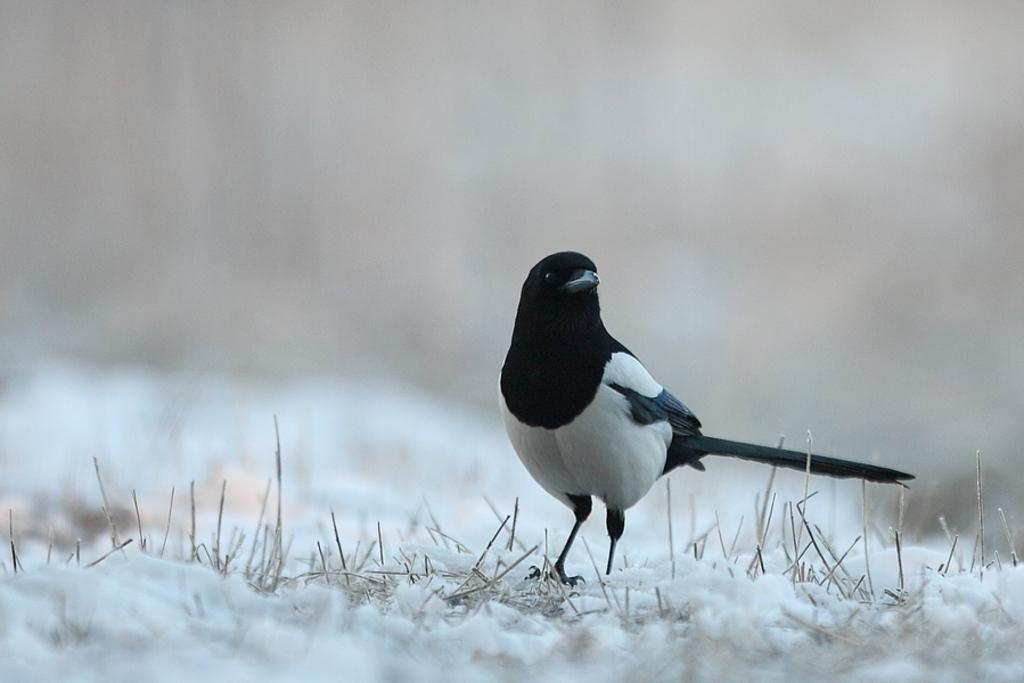What type of animal can be seen in the image? There is a bird in the image. Where is the bird located? The bird is standing on land. What is the condition of the land in the image? The land is covered with snow, and there is some grass on it. Can you describe the background of the image? The background of the image is blurry. How many sisters does the bird have in the image? There are no sisters mentioned or depicted in the image; it features a bird standing on snow-covered land. 